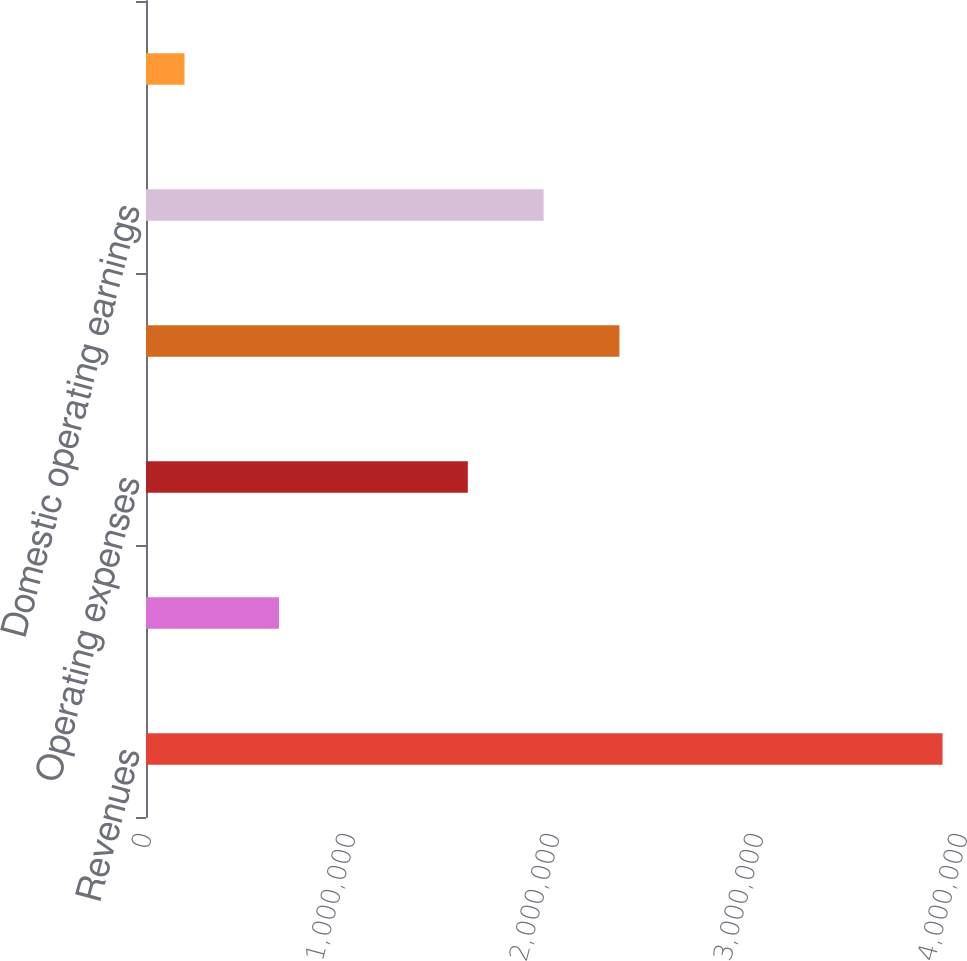Convert chart to OTSL. <chart><loc_0><loc_0><loc_500><loc_500><bar_chart><fcel>Revenues<fcel>Costs of revenue<fcel>Operating expenses<fcel>Total costs and expenses<fcel>Domestic operating earnings<fcel>Global operating earnings<nl><fcel>3.90445e+06<fcel>651826<fcel>1.57759e+06<fcel>2.32072e+06<fcel>1.94916e+06<fcel>188811<nl></chart> 